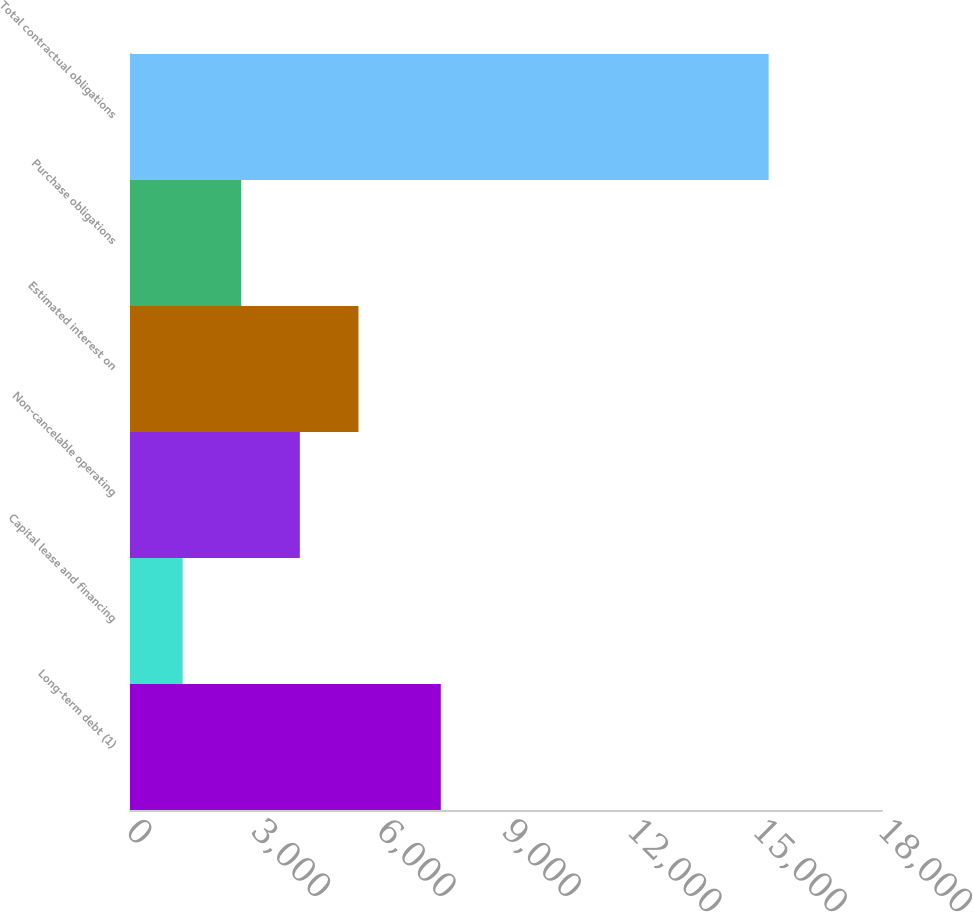Convert chart to OTSL. <chart><loc_0><loc_0><loc_500><loc_500><bar_chart><fcel>Long-term debt (1)<fcel>Capital lease and financing<fcel>Non-cancelable operating<fcel>Estimated interest on<fcel>Purchase obligations<fcel>Total contractual obligations<nl><fcel>7439<fcel>1260<fcel>4065.4<fcel>5468.1<fcel>2662.7<fcel>15287<nl></chart> 